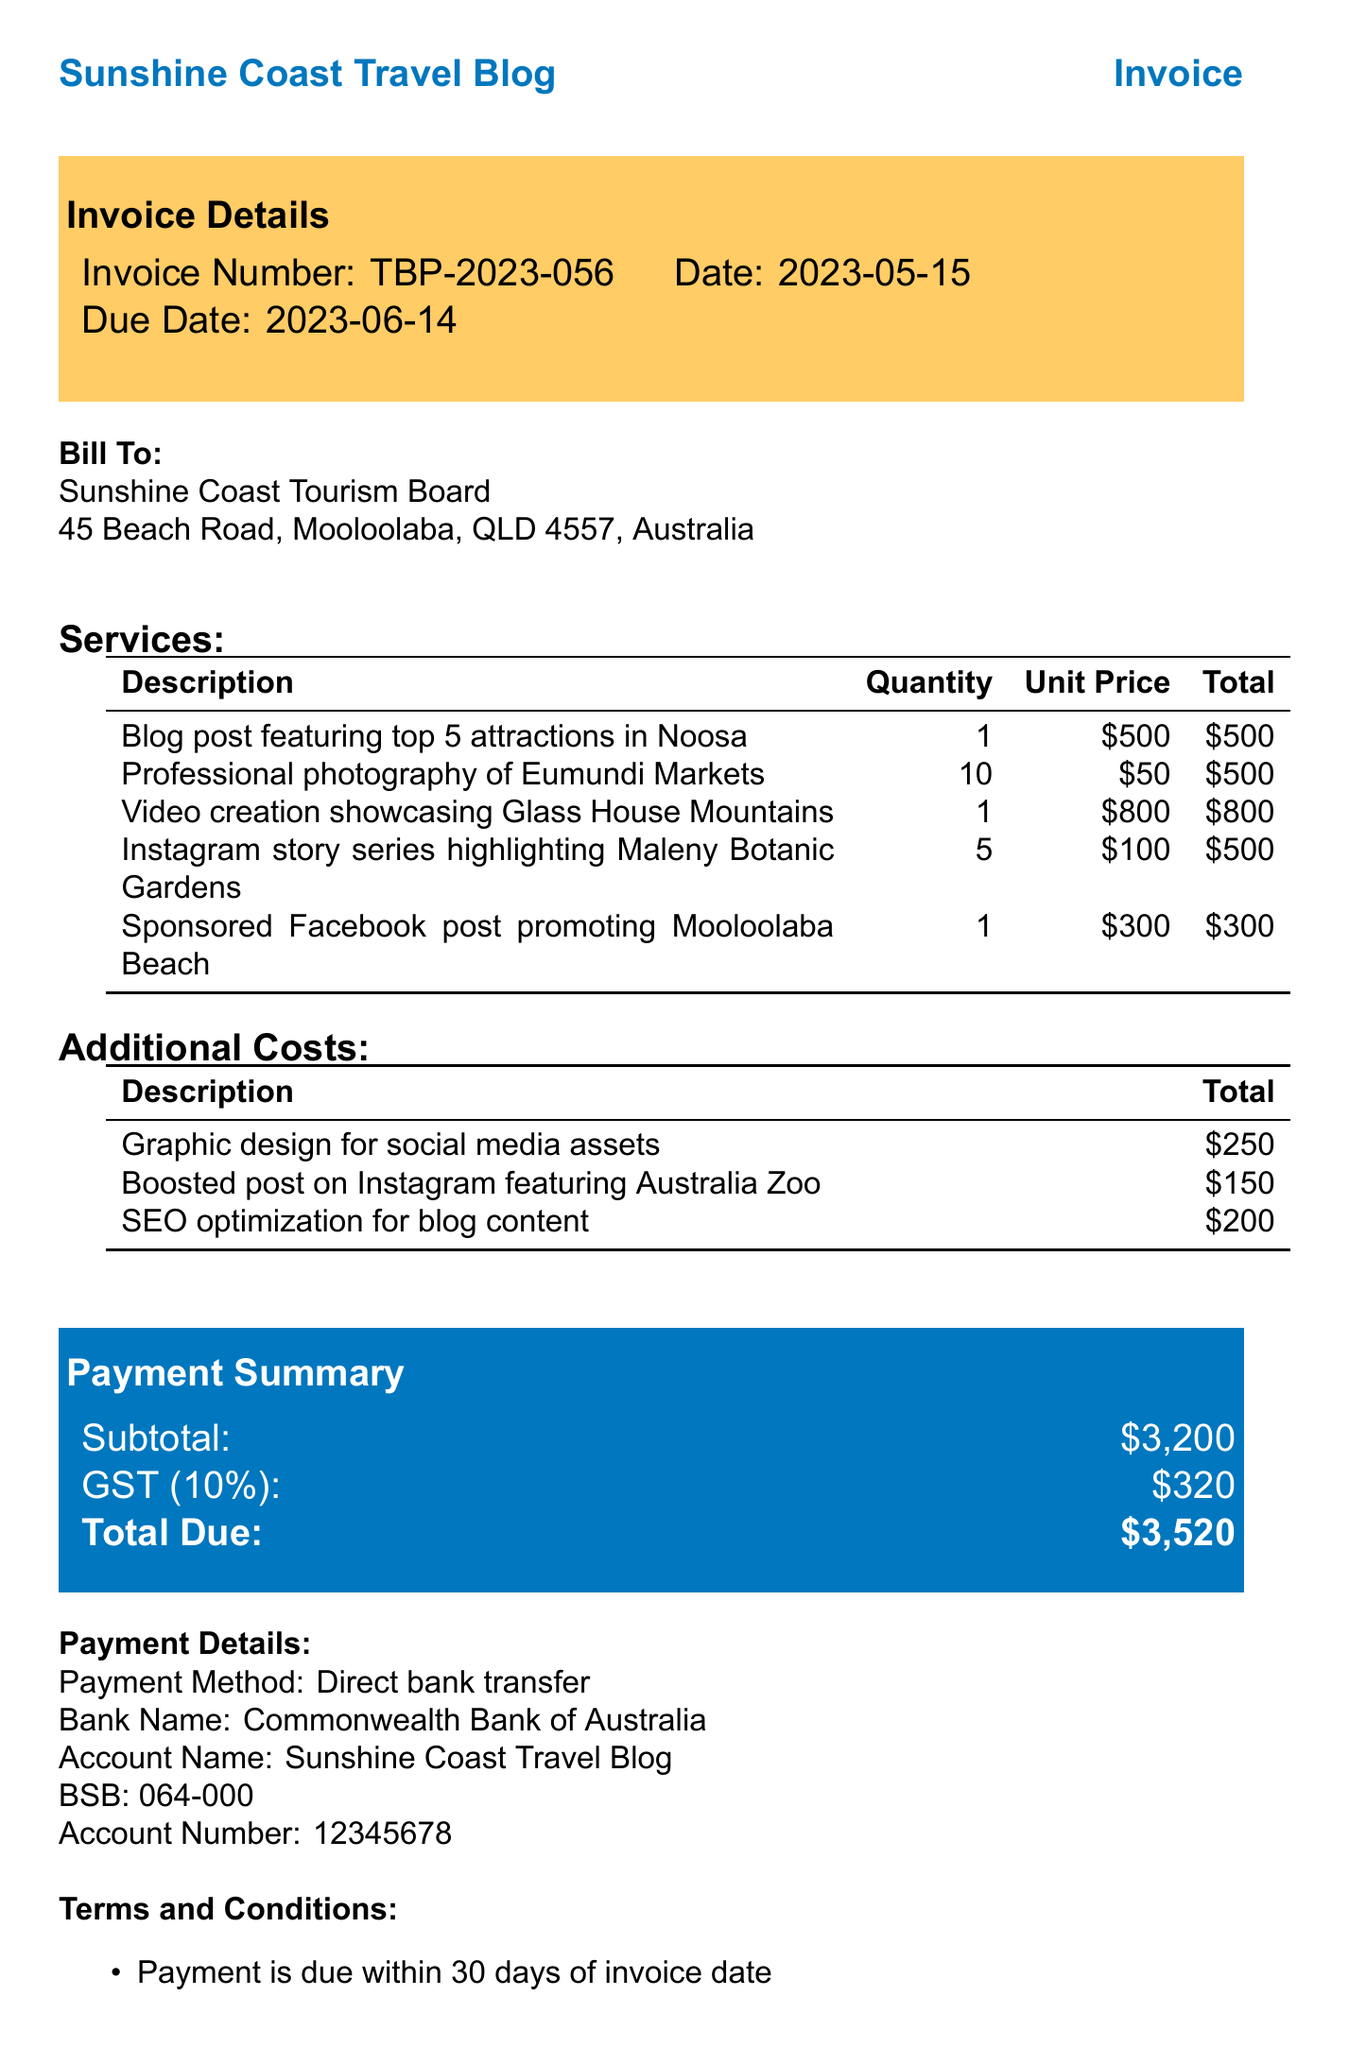What is the invoice number? The invoice number is listed under the invoice details section.
Answer: TBP-2023-056 What is the total due? The total due is provided in the payment summary section of the document.
Answer: $3,520 How many attractions are featured in the blog post? The description of the blog post states it features the top 5 attractions.
Answer: 5 What is the unit price for professional photography? The unit price for photography is specified in the services section.
Answer: $50 What is the due date for payment? The due date is listed clearly in the invoice details section.
Answer: 2023-06-14 What is the subtotal before GST? The subtotal is calculated before the addition of GST, found in the payment summary.
Answer: $3,200 What type of content creation was commissioned for Mooloolaba Beach? The description provides the type of content that was sponsored.
Answer: Facebook post How much is charged for SEO optimization? The cost for SEO optimization is shown under the additional costs section.
Answer: $200 What payment method is specified in the payment details? The method of payment is explicitly stated in the payment details section.
Answer: Direct bank transfer 